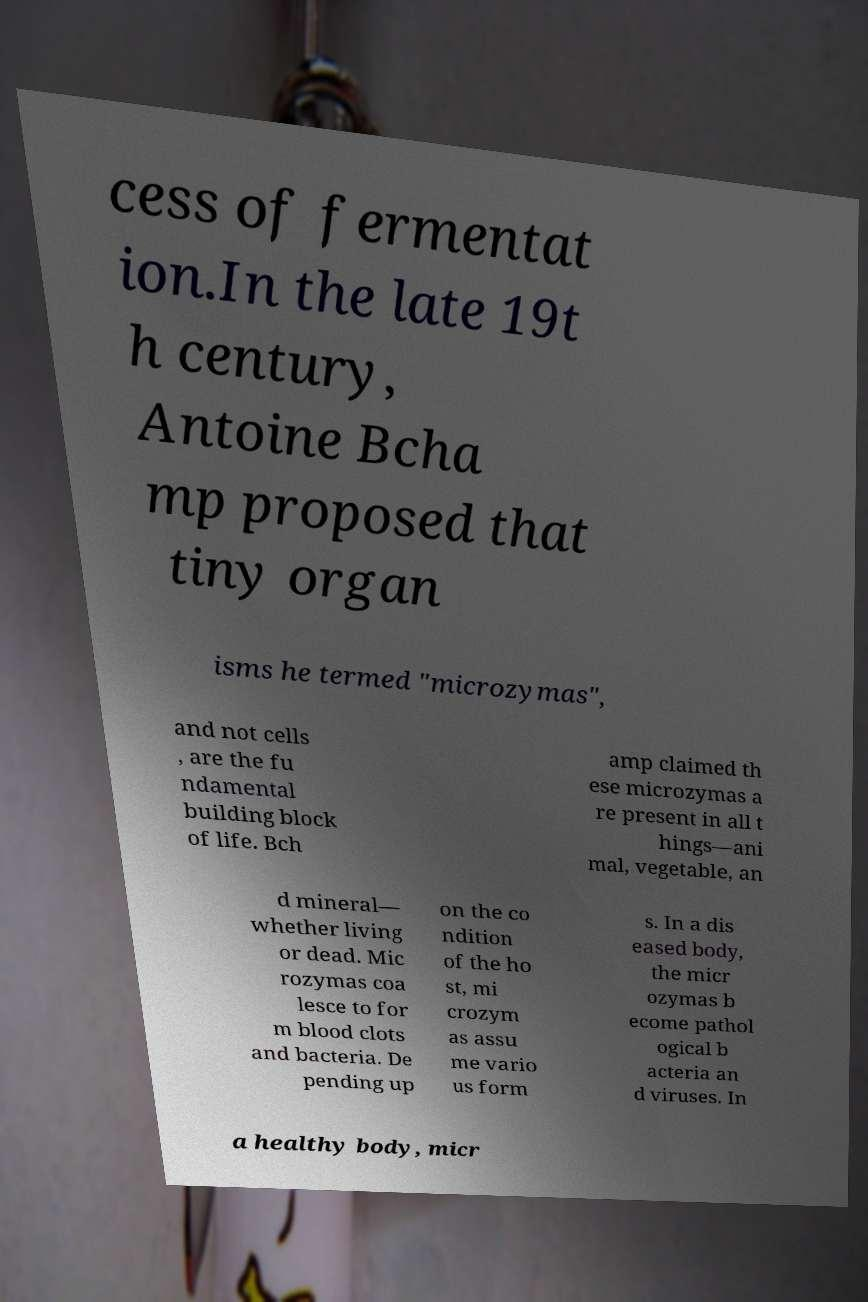For documentation purposes, I need the text within this image transcribed. Could you provide that? cess of fermentat ion.In the late 19t h century, Antoine Bcha mp proposed that tiny organ isms he termed "microzymas", and not cells , are the fu ndamental building block of life. Bch amp claimed th ese microzymas a re present in all t hings—ani mal, vegetable, an d mineral— whether living or dead. Mic rozymas coa lesce to for m blood clots and bacteria. De pending up on the co ndition of the ho st, mi crozym as assu me vario us form s. In a dis eased body, the micr ozymas b ecome pathol ogical b acteria an d viruses. In a healthy body, micr 